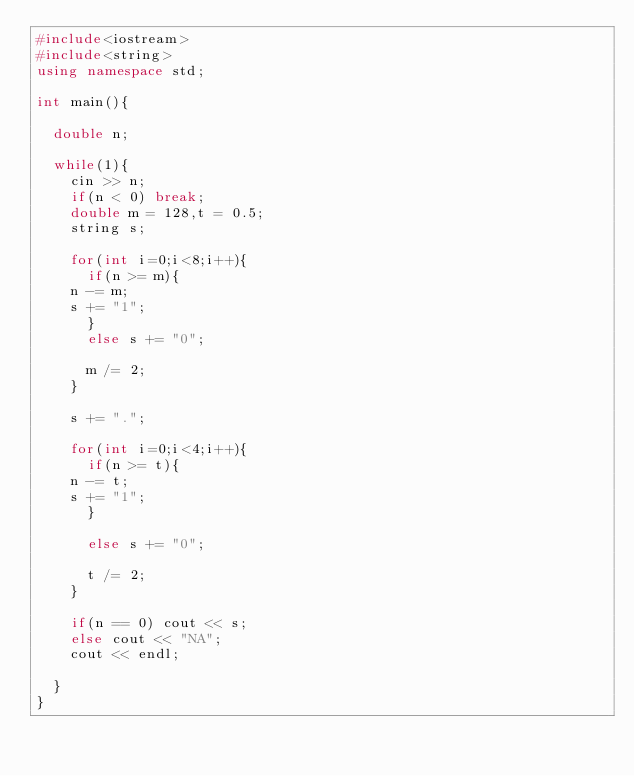<code> <loc_0><loc_0><loc_500><loc_500><_C++_>#include<iostream>
#include<string>
using namespace std;

int main(){

  double n;

  while(1){
    cin >> n;
    if(n < 0) break;
    double m = 128,t = 0.5;
    string s;

    for(int i=0;i<8;i++){
      if(n >= m){
	n -= m;
	s += "1";
      }
      else s += "0";

      m /= 2;
    }

    s += ".";

    for(int i=0;i<4;i++){
      if(n >= t){
	n -= t;
	s += "1";
      }

      else s += "0";

      t /= 2;
    }

    if(n == 0) cout << s;
    else cout << "NA";
    cout << endl;

  }
}</code> 